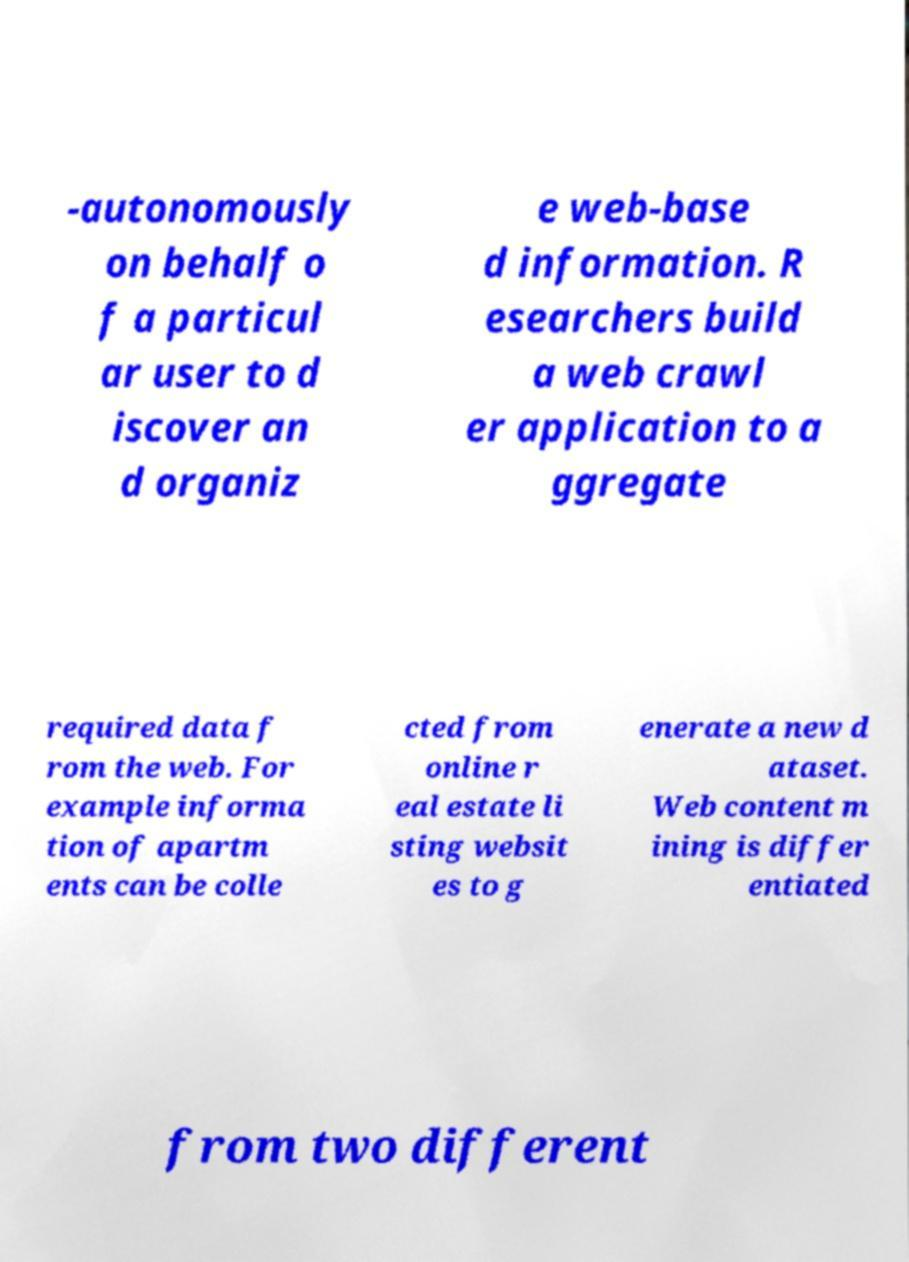Please identify and transcribe the text found in this image. -autonomously on behalf o f a particul ar user to d iscover an d organiz e web-base d information. R esearchers build a web crawl er application to a ggregate required data f rom the web. For example informa tion of apartm ents can be colle cted from online r eal estate li sting websit es to g enerate a new d ataset. Web content m ining is differ entiated from two different 